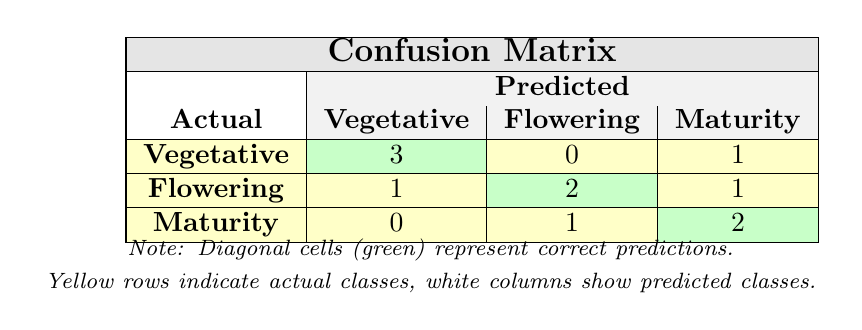What is the number of correct predictions for the Vegetative stage? The diagonal cell in the row for the Vegetative actual class indicates the correct predictions. This cell shows the value 3, meaning there are three instances where the model correctly predicted the Vegetative stage.
Answer: 3 How many instances were predicted as Flowering for the actual Maturity stage? The row for the actual Maturity stage has one entry in the Flowering column, which shows that there was one instance where Maturity was incorrectly predicted as Flowering.
Answer: 1 What is the total number of predictions made for the Flowering stage? To find the total predictions for Flowering, we need to sum all values in the Flowering column. Looking at this column, we find 0 (from Vegetative) + 2 (from Flowering) + 1 (from Maturity), which gives us 3.
Answer: 3 Does the model correctly predict any instances of Maturity as Flowering? In the row corresponding to Maturity, the value in the Flowering column is 1, indicating that there is indeed an instance of Maturity predicted as Flowering. Therefore, the answer is yes.
Answer: Yes What percentage of actual Flowering instances were correctly predicted? From the Flowering row, there are 2 correct predictions (in the Flowering column). The total instances for actual Flowering is 4 (1 as Vegetative, 2 as Flowering, and 1 as Maturity). So, the percentage of correct predictions = (2/4) * 100 = 50%.
Answer: 50% 